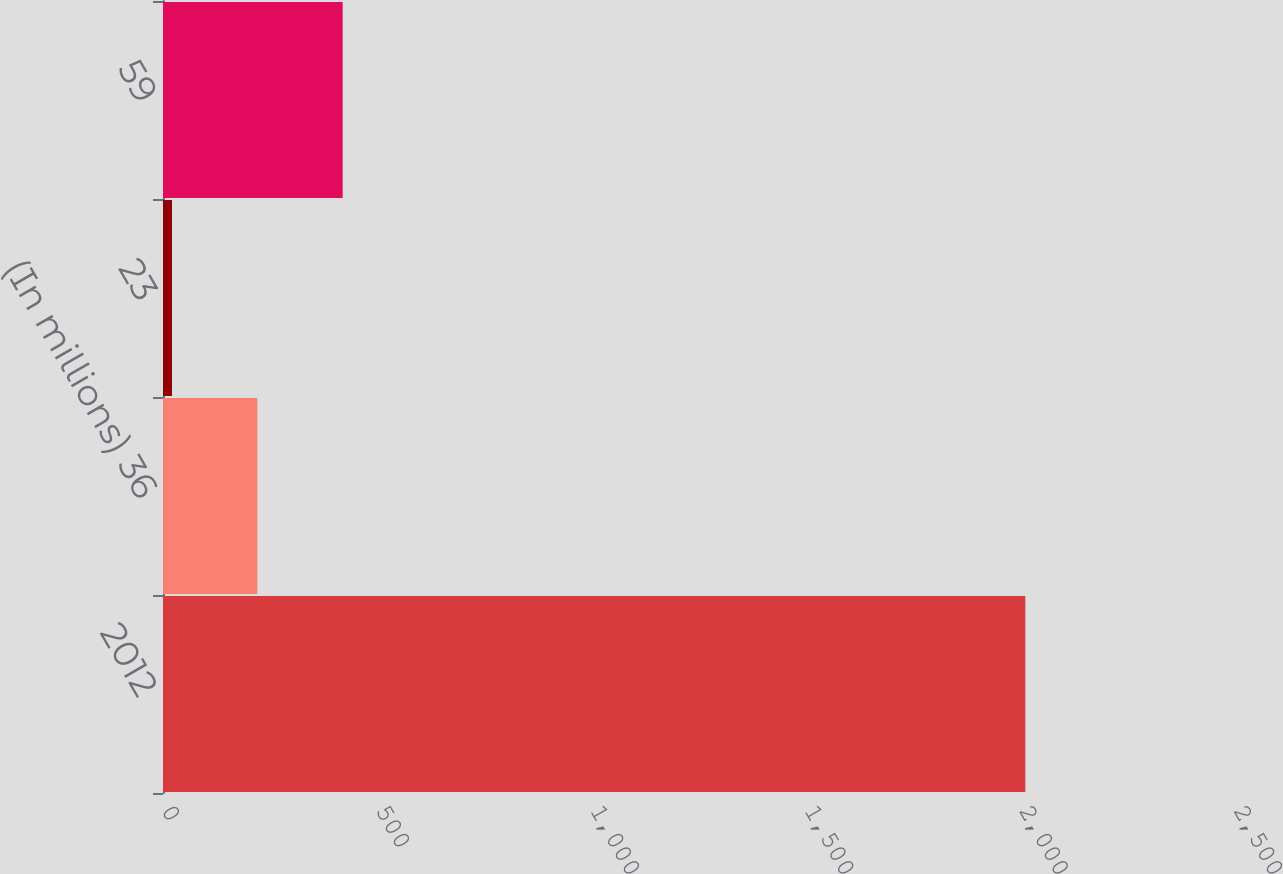Convert chart. <chart><loc_0><loc_0><loc_500><loc_500><bar_chart><fcel>2012<fcel>(In millions) 36<fcel>23<fcel>59<nl><fcel>2011<fcel>220<fcel>21<fcel>419<nl></chart> 